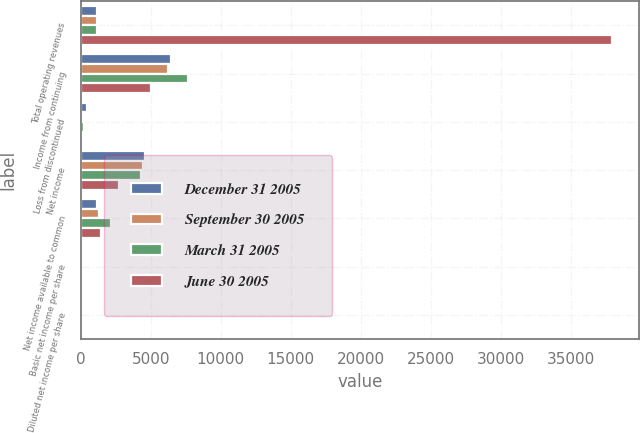Convert chart to OTSL. <chart><loc_0><loc_0><loc_500><loc_500><stacked_bar_chart><ecel><fcel>Total operating revenues<fcel>Income from continuing<fcel>Loss from discontinued<fcel>Net income<fcel>Net income available to common<fcel>Basic net income per share<fcel>Diluted net income per share<nl><fcel>December 31 2005<fcel>1157<fcel>6413<fcel>474<fcel>4602<fcel>1157<fcel>0.04<fcel>0.04<nl><fcel>September 30 2005<fcel>1157<fcel>6218<fcel>169<fcel>4425<fcel>1326<fcel>0.05<fcel>0.05<nl><fcel>March 31 2005<fcel>1157<fcel>7691<fcel>217<fcel>4335<fcel>2136<fcel>0.1<fcel>0.1<nl><fcel>June 30 2005<fcel>37967<fcel>5022<fcel>127<fcel>2739<fcel>1468<fcel>0.07<fcel>0.07<nl></chart> 